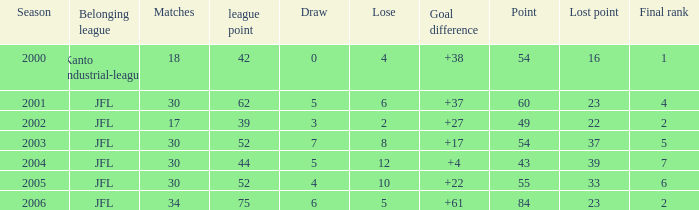I want the total number of matches for draw less than 7 and lost point of 16 with lose more than 4 0.0. 